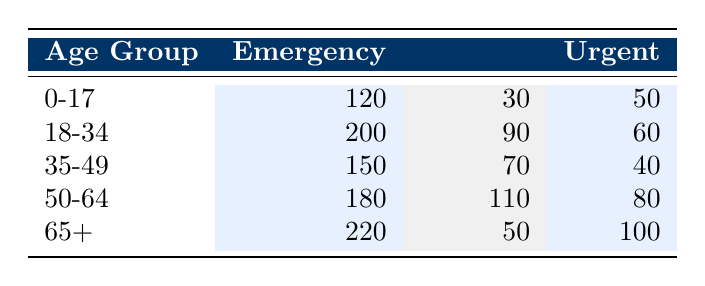What is the total number of Emergency Admissions for the age group 0-17? From the table, the Emergency Admissions for the age group 0-17 is provided as 120. Therefore, there is no need for further calculations.
Answer: 120 What is the number of Elective Admissions for the age group 50-64? The table directly shows the number of Elective Admissions for the age group 50-64 as 110. This is available in the corresponding row for that age group.
Answer: 110 How many Urgent Admissions are there for patients aged 18-34 and 35-49 combined? For the age group 18-34, Urgent Admissions are 60, and for 35-49, they are 40. By adding these two values together (60 + 40), we get a total of 100 Urgent Admissions.
Answer: 100 Is the number of Emergency Admissions higher for the age group 65+ compared to 0-17? According to the table, the Emergency Admissions for age group 65+ is 220, while for age group 0-17, it is 120. Since 220 is greater than 120, the statement is true.
Answer: Yes What is the average number of Elective Admissions across all age groups listed? The Elective Admissions from the table are: 30 (0-17), 90 (18-34), 70 (35-49), 110 (50-64), and 50 (65+). Adding these gives 30 + 90 + 70 + 110 + 50 = 350. Dividing by the number of age groups (5), the average is 350 / 5 = 70.
Answer: 70 Which age group has the highest number of Urgent Admissions, and what is that number? Checking the Urgent Admissions for all age groups, we have: 50 (0-17), 60 (18-34), 40 (35-49), 80 (50-64), and 100 (65+). The highest value is 100 for the 65+ age group.
Answer: 65+, 100 How do the total Emergency Admissions for age group 50-64 compare with those for age group 18-34? For age group 50-64, the Emergency Admissions are 180, while for age group 18-34, they are 200. Since 180 is less than 200, the total for age group 50-64 is lower.
Answer: Lower What is the total number of Admissions (Emergency, Elective, and Urgent) for the age group 35-49? The total for age group 35-49 can be calculated by summing all admissions: Emergency (150) + Elective (70) + Urgent (40) = 260. Therefore, the total for that age group is 260.
Answer: 260 Is there a higher number of Elective Admissions for patients aged 50-64 compared to those aged 65+? The table shows 110 Elective Admissions for age group 50-64 and 50 for 65+. Since 110 is greater than 50, the statement is true.
Answer: Yes 